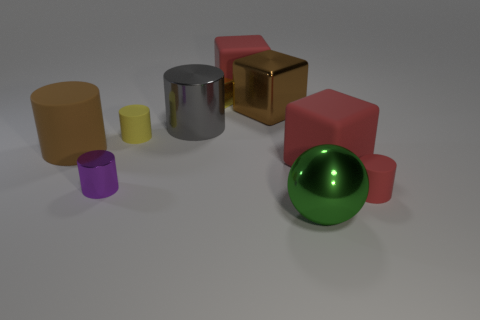What number of cylinders are both in front of the tiny yellow matte object and to the left of the gray shiny thing?
Keep it short and to the point. 2. The big metallic cylinder has what color?
Keep it short and to the point. Gray. There is a red thing that is the same shape as the tiny purple shiny object; what is its material?
Make the answer very short. Rubber. Are there any other things that are made of the same material as the gray thing?
Your answer should be compact. Yes. Is the large shiny sphere the same color as the large matte cylinder?
Provide a succinct answer. No. What shape is the red rubber object on the right side of the block that is in front of the yellow rubber thing?
Give a very brief answer. Cylinder. The green thing that is made of the same material as the gray cylinder is what shape?
Your response must be concise. Sphere. How many other things are the same shape as the purple shiny thing?
Your response must be concise. 4. There is a matte cube in front of the yellow metal cube; does it have the same size as the large gray thing?
Give a very brief answer. Yes. Is the number of big metallic spheres that are left of the small yellow shiny block greater than the number of big metal cubes?
Your response must be concise. No. 